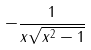<formula> <loc_0><loc_0><loc_500><loc_500>- \frac { 1 } { x \sqrt { x ^ { 2 } - 1 } }</formula> 